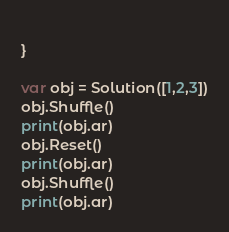<code> <loc_0><loc_0><loc_500><loc_500><_Swift_>    
}

var obj = Solution([1,2,3])
obj.Shuffle()
print(obj.ar)
obj.Reset()
print(obj.ar)
obj.Shuffle()
print(obj.ar)
</code> 